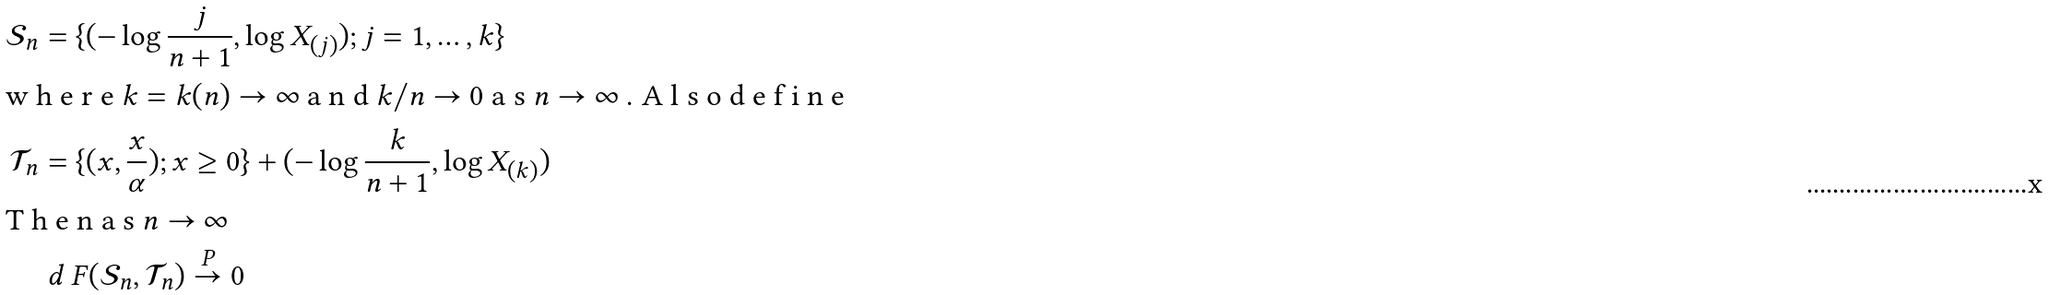Convert formula to latex. <formula><loc_0><loc_0><loc_500><loc_500>\mathcal { S } _ { n } & = \{ ( - \log { \frac { j } { n + 1 } } , \log X _ { ( j ) } ) ; j = 1 , \dots , k \} \\ \intertext { w h e r e $ k = k ( n ) \to \infty $ a n d $ k / n \to 0 $ a s $ n \to \infty $ . A l s o d e f i n e } \mathcal { T } _ { n } & = \{ ( x , \frac { x } { \alpha } ) ; x \geq 0 \} + ( - \log \frac { k } { n + 1 } , \log X _ { ( k ) } ) \\ \intertext { T h e n a s $ n \to \infty $ } & \ d _ { \ } F ( \mathcal { S } _ { n } , \mathcal { T } _ { n } ) \stackrel { P } { \to } 0</formula> 